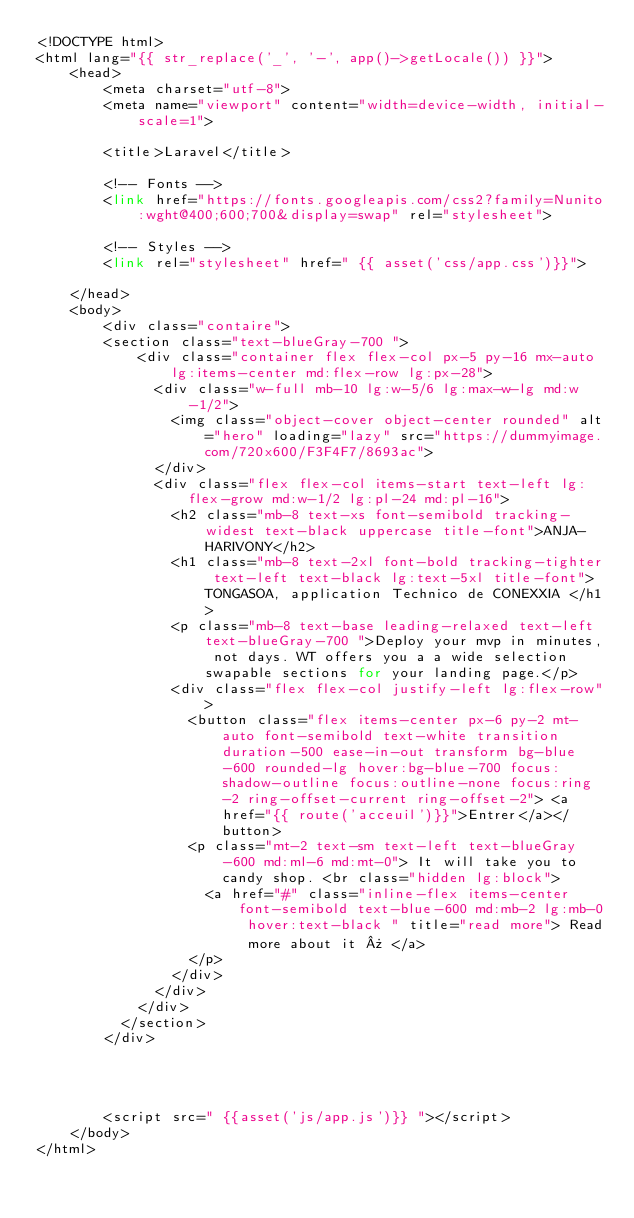<code> <loc_0><loc_0><loc_500><loc_500><_PHP_><!DOCTYPE html>
<html lang="{{ str_replace('_', '-', app()->getLocale()) }}">
    <head>
        <meta charset="utf-8">
        <meta name="viewport" content="width=device-width, initial-scale=1">

        <title>Laravel</title>

        <!-- Fonts -->
        <link href="https://fonts.googleapis.com/css2?family=Nunito:wght@400;600;700&display=swap" rel="stylesheet">

        <!-- Styles -->
        <link rel="stylesheet" href=" {{ asset('css/app.css')}}">

    </head>
    <body>
        <div class="contaire">
        <section class="text-blueGray-700 ">
            <div class="container flex flex-col px-5 py-16 mx-auto lg:items-center md:flex-row lg:px-28">
              <div class="w-full mb-10 lg:w-5/6 lg:max-w-lg md:w-1/2">
                <img class="object-cover object-center rounded" alt="hero" loading="lazy" src="https://dummyimage.com/720x600/F3F4F7/8693ac">
              </div>
              <div class="flex flex-col items-start text-left lg:flex-grow md:w-1/2 lg:pl-24 md:pl-16">
                <h2 class="mb-8 text-xs font-semibold tracking-widest text-black uppercase title-font">ANJA-HARIVONY</h2>
                <h1 class="mb-8 text-2xl font-bold tracking-tighter text-left text-black lg:text-5xl title-font">TONGASOA, application Technico de CONEXXIA </h1>
                <p class="mb-8 text-base leading-relaxed text-left text-blueGray-700 ">Deploy your mvp in minutes, not days. WT offers you a a wide selection swapable sections for your landing page.</p>
                <div class="flex flex-col justify-left lg:flex-row">
                  <button class="flex items-center px-6 py-2 mt-auto font-semibold text-white transition duration-500 ease-in-out transform bg-blue-600 rounded-lg hover:bg-blue-700 focus:shadow-outline focus:outline-none focus:ring-2 ring-offset-current ring-offset-2"> <a href="{{ route('acceuil')}}">Entrer</a></button>
                  <p class="mt-2 text-sm text-left text-blueGray-600 md:ml-6 md:mt-0"> It will take you to candy shop. <br class="hidden lg:block">
                    <a href="#" class="inline-flex items-center font-semibold text-blue-600 md:mb-2 lg:mb-0 hover:text-black " title="read more"> Read more about it » </a>
                  </p>
                </div>
              </div>
            </div>
          </section>
        </div>
        



        <script src=" {{asset('js/app.js')}} "></script>
    </body>
</html>
</code> 